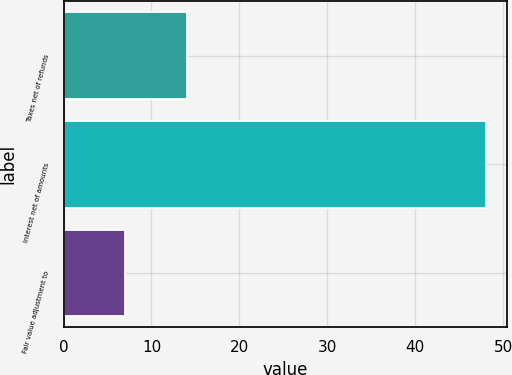Convert chart to OTSL. <chart><loc_0><loc_0><loc_500><loc_500><bar_chart><fcel>Taxes net of refunds<fcel>Interest net of amounts<fcel>Fair value adjustment to<nl><fcel>14<fcel>48<fcel>7<nl></chart> 